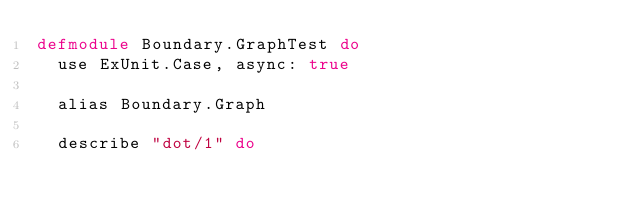<code> <loc_0><loc_0><loc_500><loc_500><_Elixir_>defmodule Boundary.GraphTest do
  use ExUnit.Case, async: true

  alias Boundary.Graph

  describe "dot/1" do</code> 